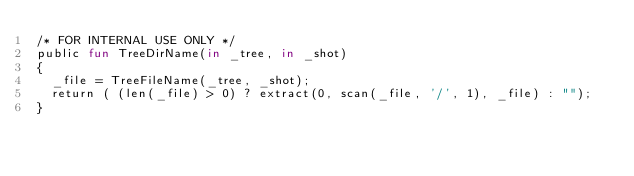Convert code to text. <code><loc_0><loc_0><loc_500><loc_500><_SML_>/* FOR INTERNAL USE ONLY */
public fun TreeDirName(in _tree, in _shot)
{
  _file = TreeFileName(_tree, _shot);
  return ( (len(_file) > 0) ? extract(0, scan(_file, '/', 1), _file) : "");
}
</code> 